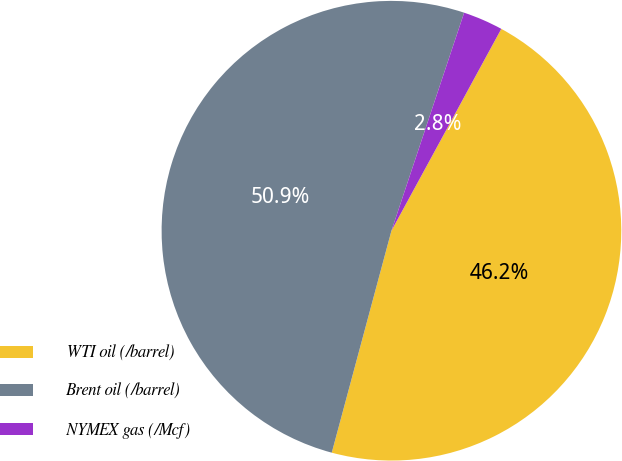<chart> <loc_0><loc_0><loc_500><loc_500><pie_chart><fcel>WTI oil (/barrel)<fcel>Brent oil (/barrel)<fcel>NYMEX gas (/Mcf)<nl><fcel>46.25%<fcel>50.94%<fcel>2.81%<nl></chart> 